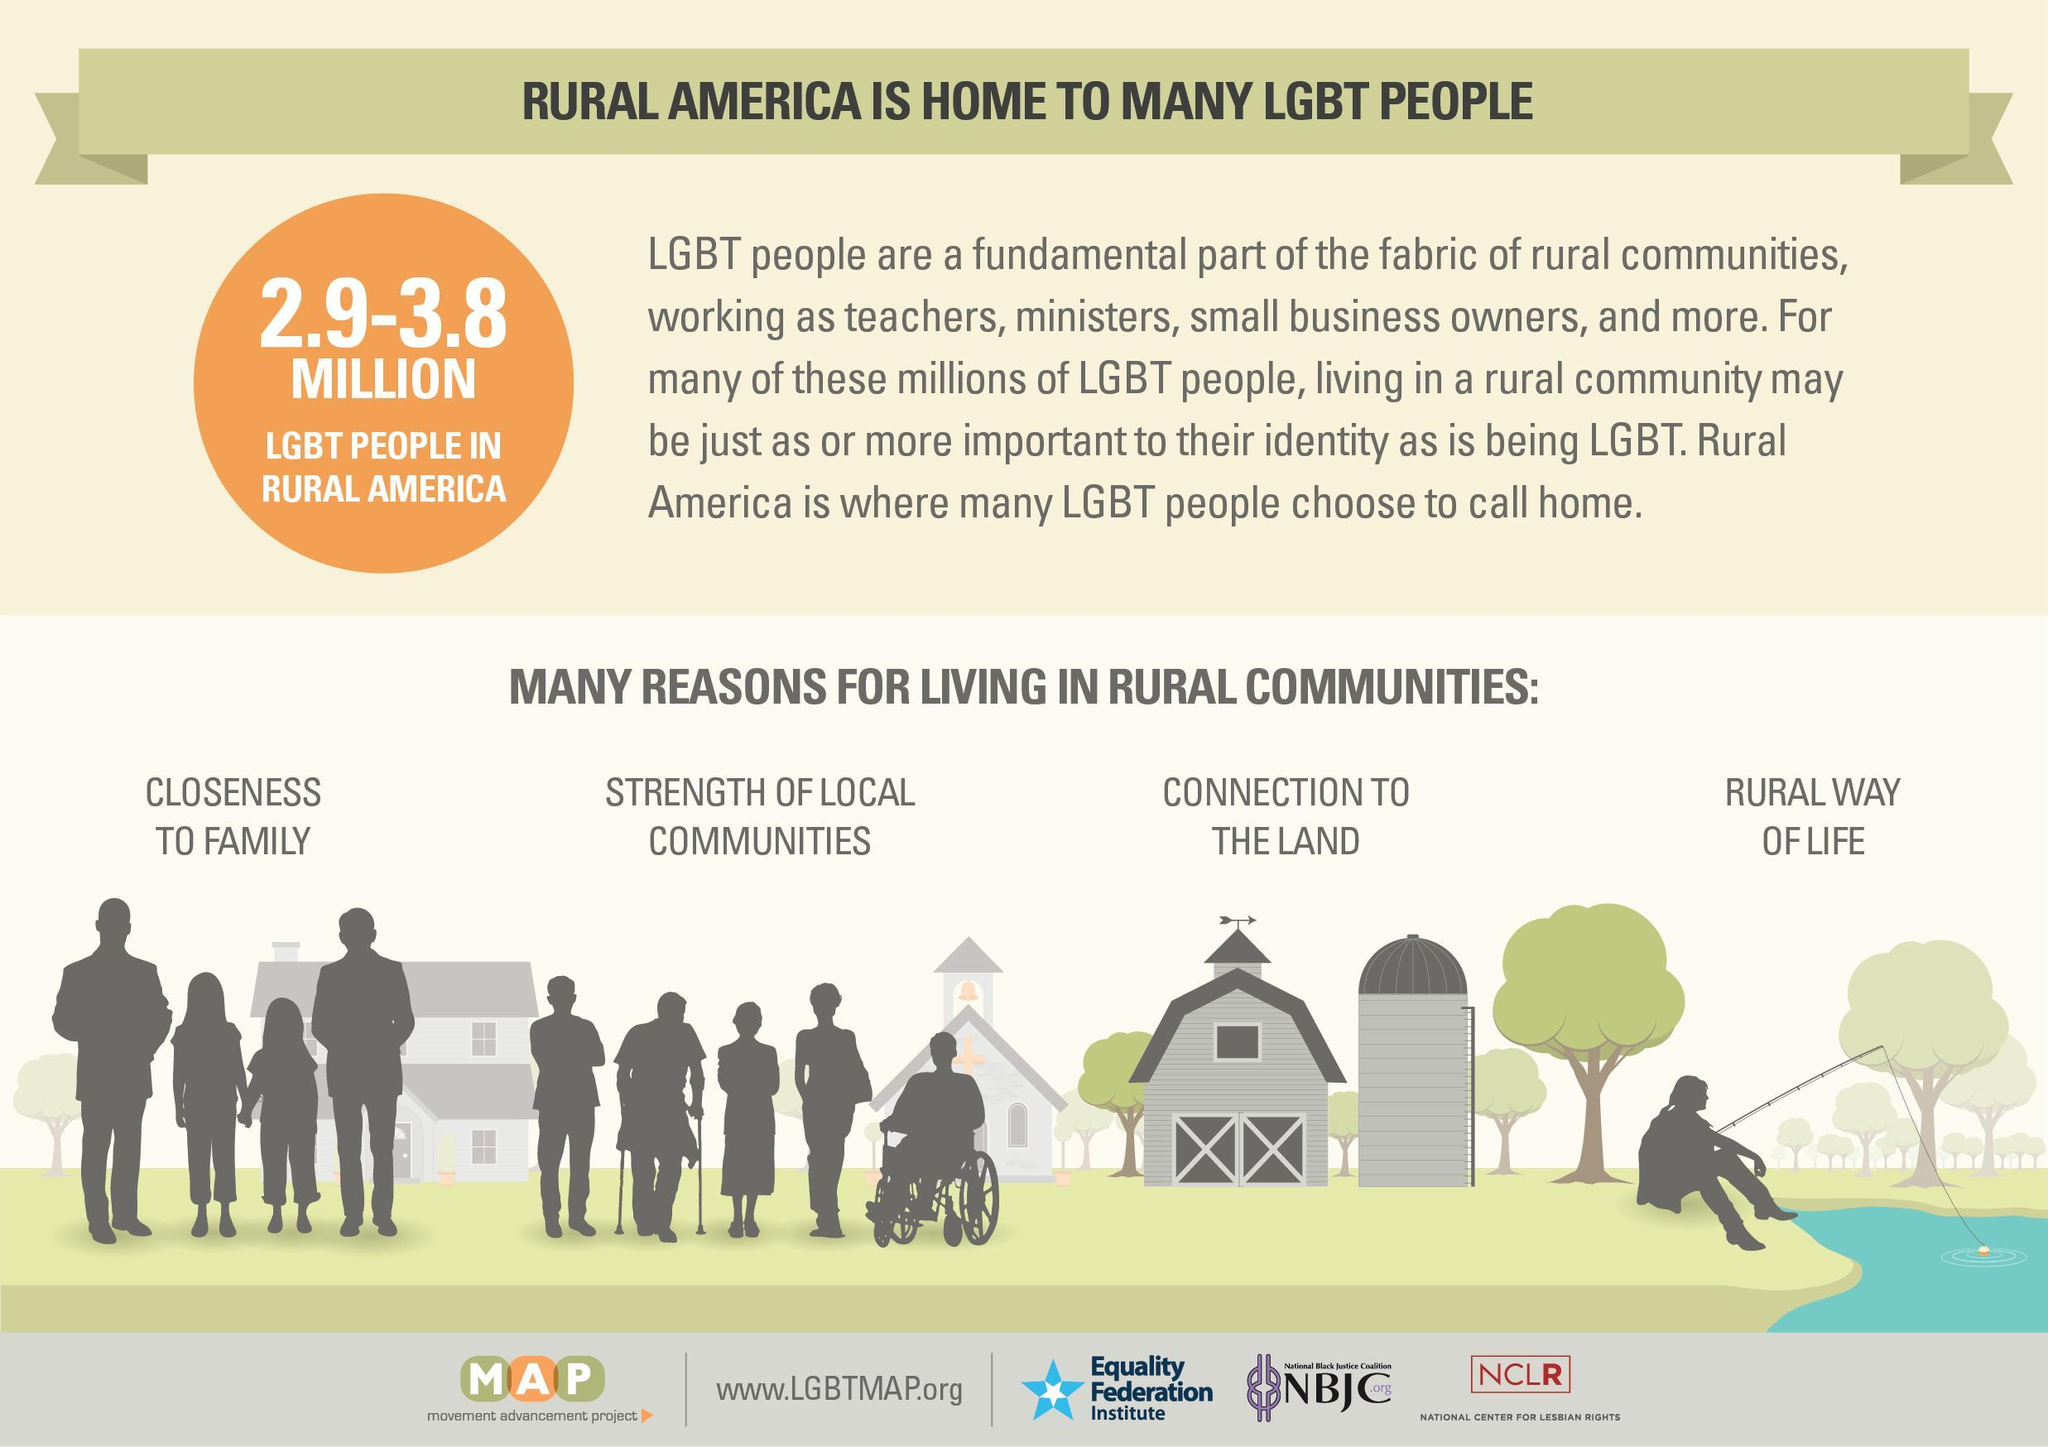What is the population of LGBT people in rural America?
Answer the question with a short phrase. 2.9-3.8 MILLION 